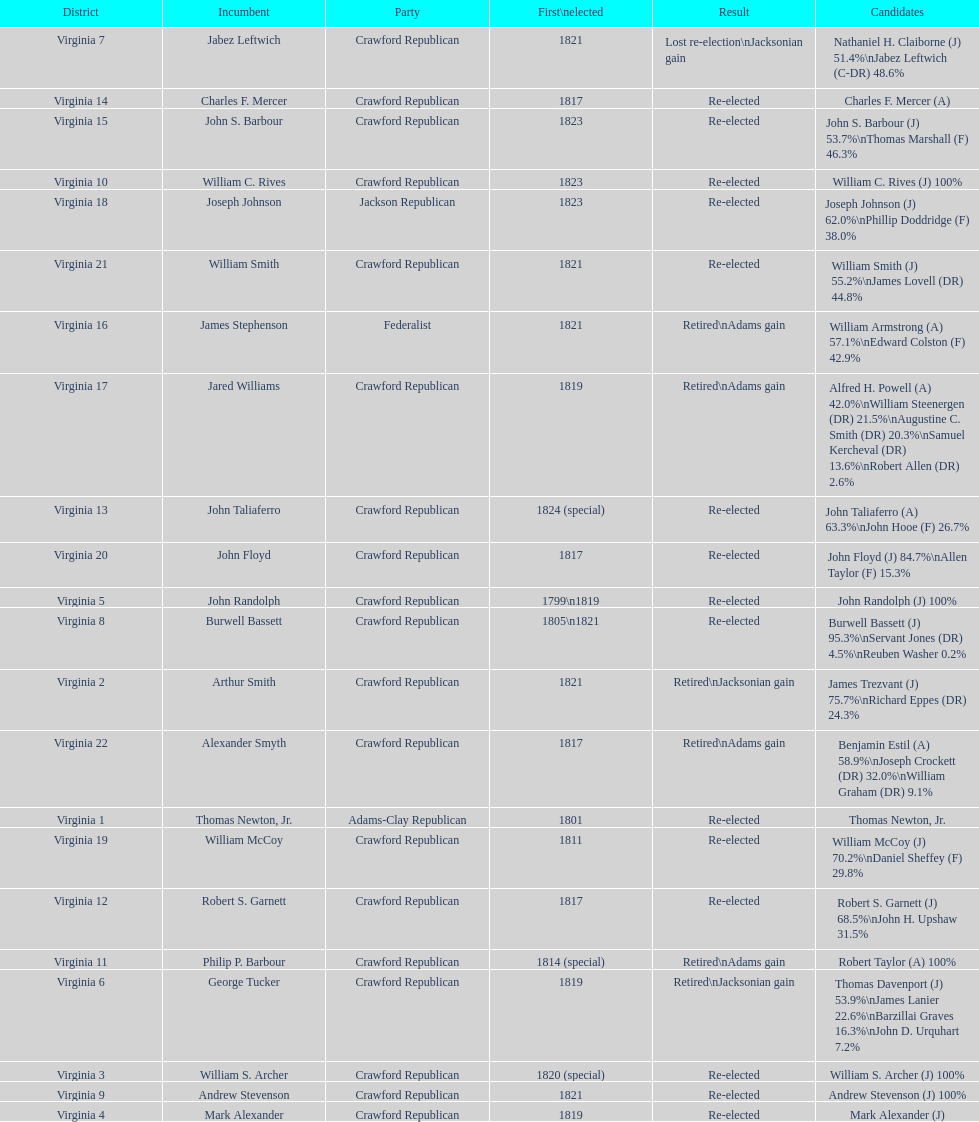Can you give me this table as a dict? {'header': ['District', 'Incumbent', 'Party', 'First\\nelected', 'Result', 'Candidates'], 'rows': [['Virginia 7', 'Jabez Leftwich', 'Crawford Republican', '1821', 'Lost re-election\\nJacksonian gain', 'Nathaniel H. Claiborne (J) 51.4%\\nJabez Leftwich (C-DR) 48.6%'], ['Virginia 14', 'Charles F. Mercer', 'Crawford Republican', '1817', 'Re-elected', 'Charles F. Mercer (A)'], ['Virginia 15', 'John S. Barbour', 'Crawford Republican', '1823', 'Re-elected', 'John S. Barbour (J) 53.7%\\nThomas Marshall (F) 46.3%'], ['Virginia 10', 'William C. Rives', 'Crawford Republican', '1823', 'Re-elected', 'William C. Rives (J) 100%'], ['Virginia 18', 'Joseph Johnson', 'Jackson Republican', '1823', 'Re-elected', 'Joseph Johnson (J) 62.0%\\nPhillip Doddridge (F) 38.0%'], ['Virginia 21', 'William Smith', 'Crawford Republican', '1821', 'Re-elected', 'William Smith (J) 55.2%\\nJames Lovell (DR) 44.8%'], ['Virginia 16', 'James Stephenson', 'Federalist', '1821', 'Retired\\nAdams gain', 'William Armstrong (A) 57.1%\\nEdward Colston (F) 42.9%'], ['Virginia 17', 'Jared Williams', 'Crawford Republican', '1819', 'Retired\\nAdams gain', 'Alfred H. Powell (A) 42.0%\\nWilliam Steenergen (DR) 21.5%\\nAugustine C. Smith (DR) 20.3%\\nSamuel Kercheval (DR) 13.6%\\nRobert Allen (DR) 2.6%'], ['Virginia 13', 'John Taliaferro', 'Crawford Republican', '1824 (special)', 'Re-elected', 'John Taliaferro (A) 63.3%\\nJohn Hooe (F) 26.7%'], ['Virginia 20', 'John Floyd', 'Crawford Republican', '1817', 'Re-elected', 'John Floyd (J) 84.7%\\nAllen Taylor (F) 15.3%'], ['Virginia 5', 'John Randolph', 'Crawford Republican', '1799\\n1819', 'Re-elected', 'John Randolph (J) 100%'], ['Virginia 8', 'Burwell Bassett', 'Crawford Republican', '1805\\n1821', 'Re-elected', 'Burwell Bassett (J) 95.3%\\nServant Jones (DR) 4.5%\\nReuben Washer 0.2%'], ['Virginia 2', 'Arthur Smith', 'Crawford Republican', '1821', 'Retired\\nJacksonian gain', 'James Trezvant (J) 75.7%\\nRichard Eppes (DR) 24.3%'], ['Virginia 22', 'Alexander Smyth', 'Crawford Republican', '1817', 'Retired\\nAdams gain', 'Benjamin Estil (A) 58.9%\\nJoseph Crockett (DR) 32.0%\\nWilliam Graham (DR) 9.1%'], ['Virginia 1', 'Thomas Newton, Jr.', 'Adams-Clay Republican', '1801', 'Re-elected', 'Thomas Newton, Jr.'], ['Virginia 19', 'William McCoy', 'Crawford Republican', '1811', 'Re-elected', 'William McCoy (J) 70.2%\\nDaniel Sheffey (F) 29.8%'], ['Virginia 12', 'Robert S. Garnett', 'Crawford Republican', '1817', 'Re-elected', 'Robert S. Garnett (J) 68.5%\\nJohn H. Upshaw 31.5%'], ['Virginia 11', 'Philip P. Barbour', 'Crawford Republican', '1814 (special)', 'Retired\\nAdams gain', 'Robert Taylor (A) 100%'], ['Virginia 6', 'George Tucker', 'Crawford Republican', '1819', 'Retired\\nJacksonian gain', 'Thomas Davenport (J) 53.9%\\nJames Lanier 22.6%\\nBarzillai Graves 16.3%\\nJohn D. Urquhart 7.2%'], ['Virginia 3', 'William S. Archer', 'Crawford Republican', '1820 (special)', 'Re-elected', 'William S. Archer (J) 100%'], ['Virginia 9', 'Andrew Stevenson', 'Crawford Republican', '1821', 'Re-elected', 'Andrew Stevenson (J) 100%'], ['Virginia 4', 'Mark Alexander', 'Crawford Republican', '1819', 'Re-elected', 'Mark Alexander (J)']]} What is the last party on this chart? Crawford Republican. 